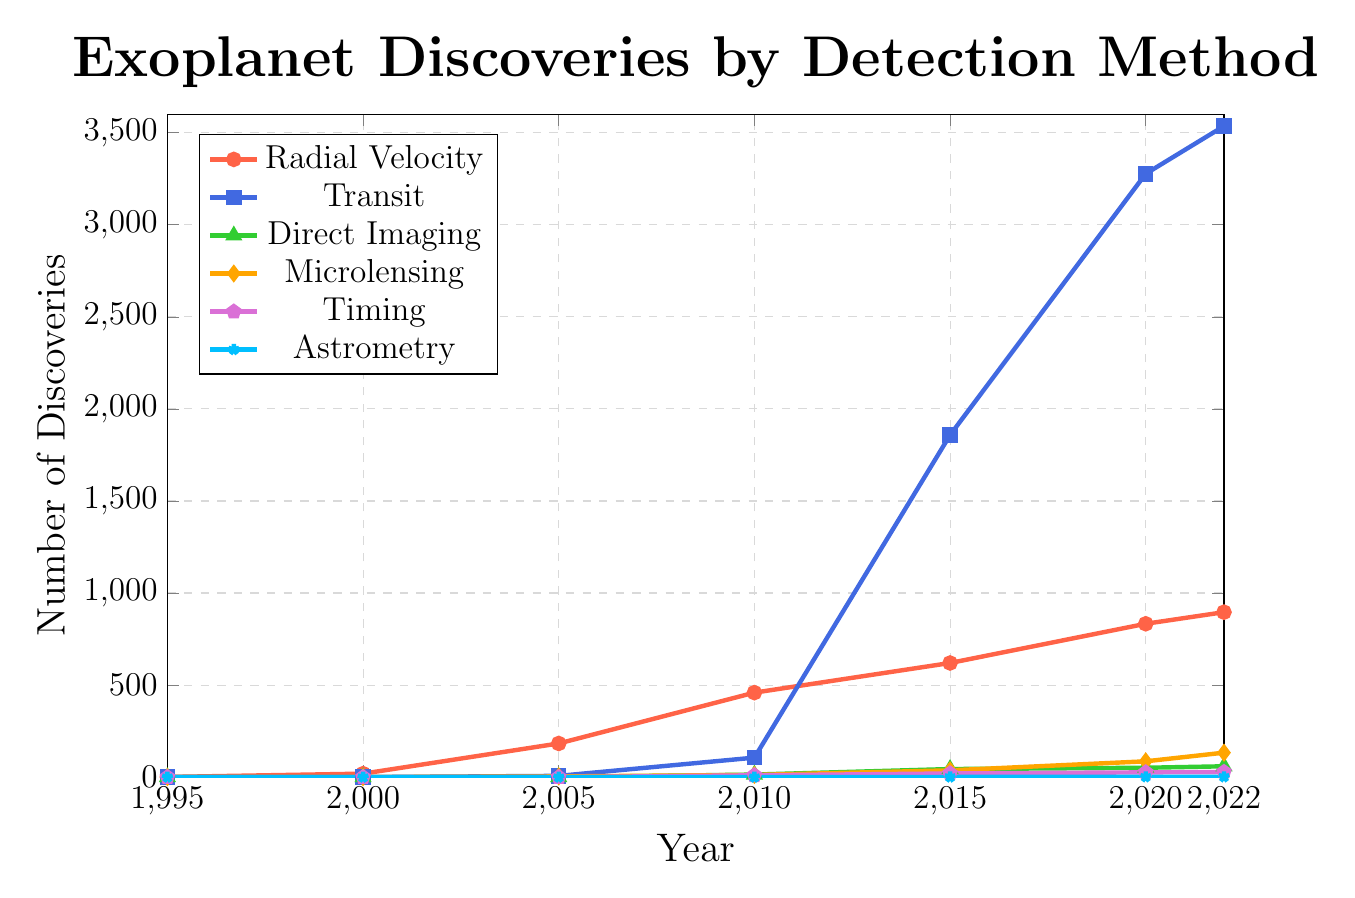What's the total number of exoplanet discoveries in 2022? Sum the values for all detection methods in 2022: 896 (Radial Velocity) + 3536 (Transit) + 59 (Direct Imaging) + 133 (Microlensing) + 28 (Timing) + 2 (Astrometry) = 4654
Answer: 4654 Which detection method saw the largest increase in discoveries between 2010 and 2015? Calculate the increase for each method from 2010 to 2015: Radial Velocity: 620 - 459 = 161, Transit: 1858 - 106 = 1752, Direct Imaging: 44 - 14 = 30, Microlensing: 37 - 12 = 25, Timing: 20 - 10 = 10, Astrometry: 1 - 0 = 1. The largest increase is for Transit (1752)
Answer: Transit How many more exoplanets were discovered using the Transit method than the Radial Velocity method in 2020? Calculate the difference: 3277 (Transit) - 833 (Radial Velocity) = 2444
Answer: 2444 Which detection method had the fewest discoveries overall across all years? Sum the values for all years for each detection method and compare: Astrometry (0 + 0 + 0 + 0 + 1 + 2 + 2 = 5) has the fewest
Answer: Astrometry What's the average yearly number of exoplanet discoveries for the Direct Imaging method from 2005 to 2022? Calculate the sum of Direct Imaging discoveries and divide by the number of years (7 years): (0 + 14 + 44 + 51 + 59) / 5 = 33.6 ≈ 34
Answer: 34 In which year did the Microlensing method see its largest increase in discoveries compared to the previous recorded year? Compare year-over-year increases: 2010-2005 (12 - 4 = 8), 2015-2010 (37 - 12 = 25), 2020-2015 (86 - 37 = 49), and 2022-2020 (133 - 86 = 47). The largest increase is from 2015 to 2020 (49)
Answer: 2020 How many total discoveries were made using the Radial Velocity and Timing methods combined in 2010? Sum the values of Radial Velocity and Timing in 2010: 459 (Radial Velocity) + 10 (Timing) = 469
Answer: 469 What's the percentage increase in Transit method discoveries from 2015 to 2022? Calculate the percentage increase: (3536 - 1858) / 1858 * 100 = 90.33%
Answer: 90.33% In which year did the Radial Velocity method first surpass 500 discoveries? Identify the year when Radial Velocity discoveries exceed 500 for the first time: It's the value between 2010 (459) and 2015 (620), so the year is 2015
Answer: 2015 